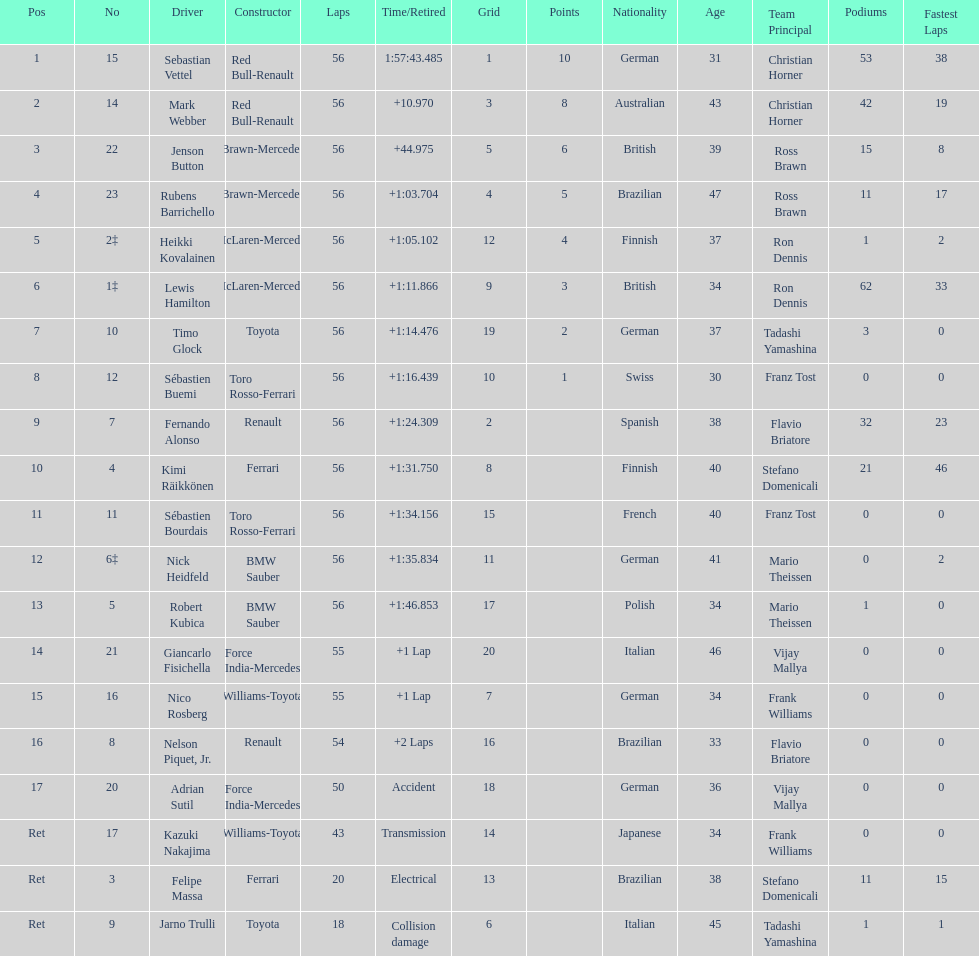Who was the shared constructor of heikki kovalainen and lewis hamilton? McLaren-Mercedes. 